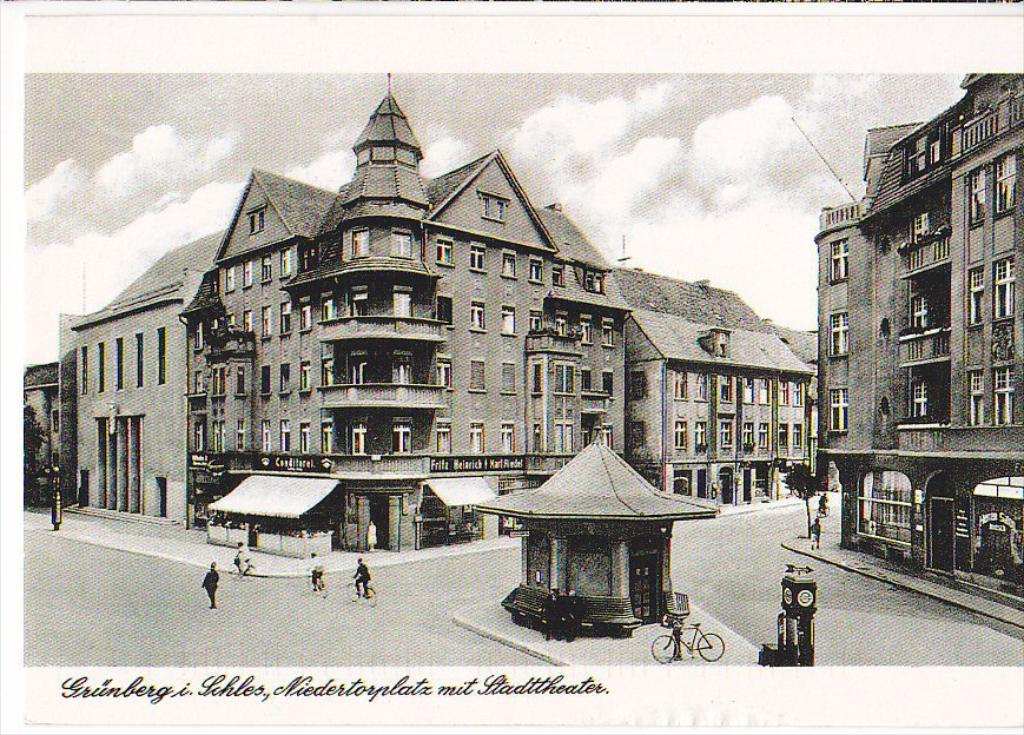How would you summarize this image in a sentence or two? There are buildings with windows, balcony, doors. Also there are roads. Some people are there on the roads. And there is a clock. There are cycles. Some people are riding cycles. In the background there is sky. There is a watermark on the image. 